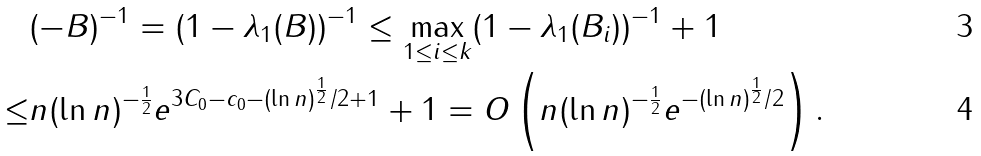<formula> <loc_0><loc_0><loc_500><loc_500>& \| ( - B ) ^ { - 1 } \| = ( 1 - \lambda _ { 1 } ( B ) ) ^ { - 1 } \leq \max _ { 1 \leq i \leq k } ( 1 - \lambda _ { 1 } ( B _ { i } ) ) ^ { - 1 } + 1 \\ \leq & n ( \ln n ) ^ { - \frac { 1 } { 2 } } e ^ { 3 C _ { 0 } - c _ { 0 } - ( \ln n ) ^ { \frac { 1 } { 2 } } / 2 + 1 } + 1 = O \left ( n ( \ln n ) ^ { - \frac { 1 } { 2 } } e ^ { - ( \ln n ) ^ { \frac { 1 } { 2 } } / 2 } \right ) .</formula> 